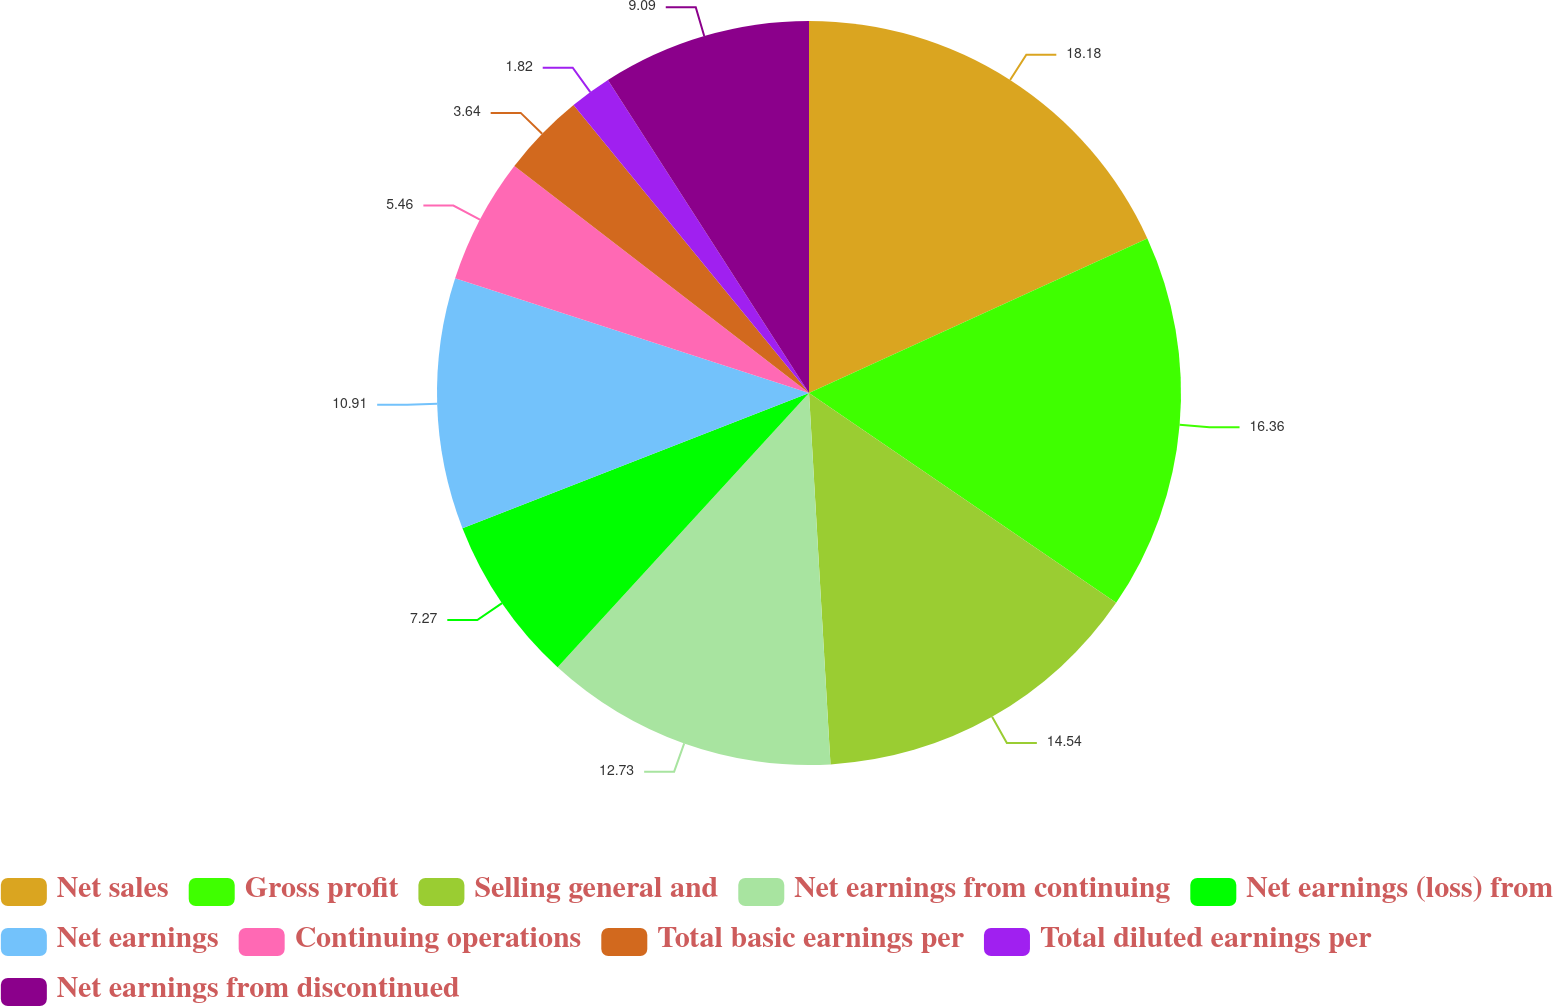Convert chart to OTSL. <chart><loc_0><loc_0><loc_500><loc_500><pie_chart><fcel>Net sales<fcel>Gross profit<fcel>Selling general and<fcel>Net earnings from continuing<fcel>Net earnings (loss) from<fcel>Net earnings<fcel>Continuing operations<fcel>Total basic earnings per<fcel>Total diluted earnings per<fcel>Net earnings from discontinued<nl><fcel>18.18%<fcel>16.36%<fcel>14.54%<fcel>12.73%<fcel>7.27%<fcel>10.91%<fcel>5.46%<fcel>3.64%<fcel>1.82%<fcel>9.09%<nl></chart> 